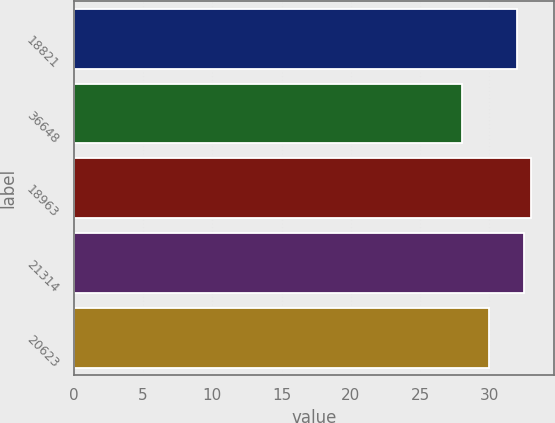<chart> <loc_0><loc_0><loc_500><loc_500><bar_chart><fcel>18821<fcel>36648<fcel>18963<fcel>21314<fcel>20623<nl><fcel>32<fcel>28<fcel>33<fcel>32.5<fcel>30<nl></chart> 